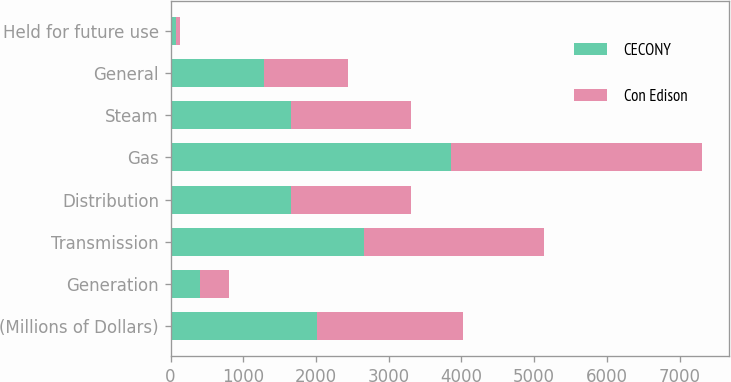Convert chart. <chart><loc_0><loc_0><loc_500><loc_500><stacked_bar_chart><ecel><fcel>(Millions of Dollars)<fcel>Generation<fcel>Transmission<fcel>Distribution<fcel>Gas<fcel>Steam<fcel>General<fcel>Held for future use<nl><fcel>CECONY<fcel>2011<fcel>400<fcel>2654<fcel>1651<fcel>3858<fcel>1651<fcel>1282<fcel>74<nl><fcel>Con Edison<fcel>2011<fcel>400<fcel>2476<fcel>1651<fcel>3455<fcel>1651<fcel>1162<fcel>62<nl></chart> 